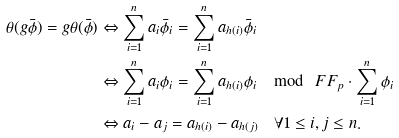Convert formula to latex. <formula><loc_0><loc_0><loc_500><loc_500>\theta ( g \bar { \phi } ) = g \theta ( \bar { \phi } ) & \Leftrightarrow \sum _ { i = 1 } ^ { n } a _ { i } \bar { \phi } _ { i } = \sum _ { i = 1 } ^ { n } a _ { h ( i ) } \bar { \phi } _ { i } \\ & \Leftrightarrow \sum _ { i = 1 } ^ { n } a _ { i } \phi _ { i } = \sum _ { i = 1 } ^ { n } a _ { h ( i ) } \phi _ { i } \mod \ F F _ { p } \cdot \sum _ { i = 1 } ^ { n } \phi _ { i } \\ & \Leftrightarrow a _ { i } - a _ { j } = a _ { h ( i ) } - a _ { h ( j ) } \quad \forall 1 \leq i , j \leq n .</formula> 